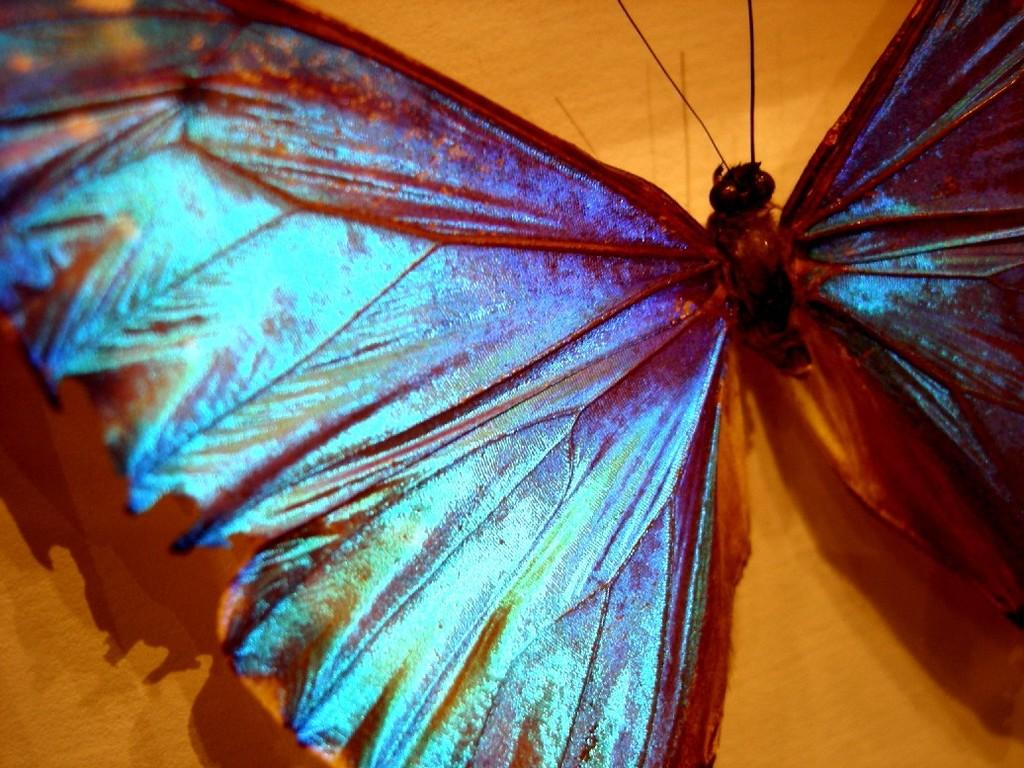What type of creature can be seen in the image? There is an insect in the image. What color is the background of the image? The background of the image is brown. What type of memory is the insect using to recall past events in the image? There is no indication in the image that the insect is using any type of memory to recall past events. 